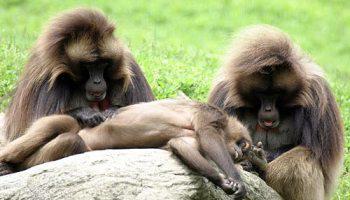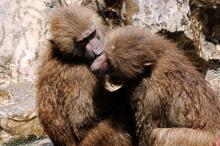The first image is the image on the left, the second image is the image on the right. For the images shown, is this caption "An image shows two sitting adult monkeys, plus a smaller monkey in the middle of the scene." true? Answer yes or no. Yes. The first image is the image on the left, the second image is the image on the right. Considering the images on both sides, is "One animal is on another animal's back in one of the images." valid? Answer yes or no. No. 